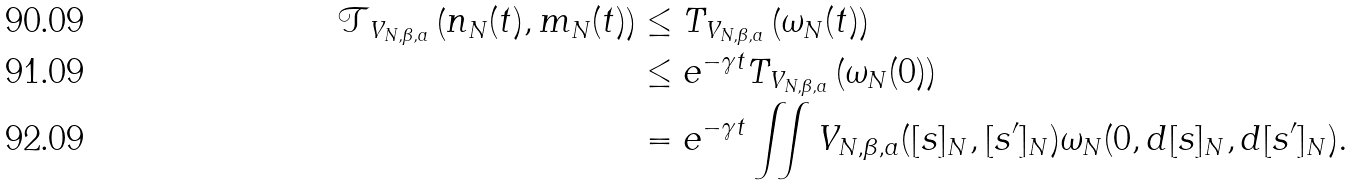Convert formula to latex. <formula><loc_0><loc_0><loc_500><loc_500>\mathcal { T } _ { V _ { N , \beta , a } } \left ( n _ { N } ( t ) , m _ { N } ( t ) \right ) & \leq T _ { V _ { N , \beta , a } } \left ( \omega _ { N } ( t ) \right ) \\ & \leq e ^ { - \gamma t } T _ { V _ { N , \beta , a } } \left ( \omega _ { N } ( 0 ) \right ) \\ & = e ^ { - \gamma t } \iint V _ { N , \beta , a } ( [ s ] _ { N } , [ s ^ { \prime } ] _ { N } ) \omega _ { N } ( 0 , d [ s ] _ { N } , d [ s ^ { \prime } ] _ { N } ) .</formula> 